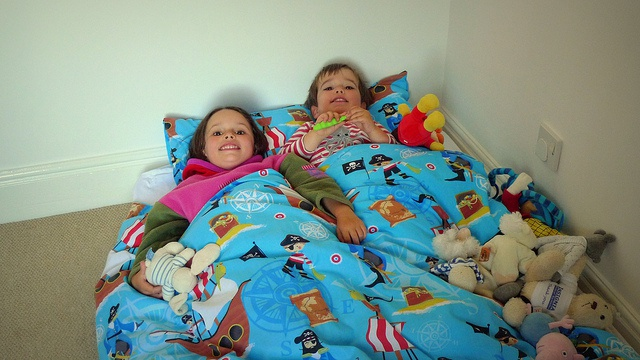Describe the objects in this image and their specific colors. I can see people in darkgray, darkgreen, black, brown, and purple tones, people in darkgray, brown, tan, and black tones, teddy bear in darkgray, tan, gray, and olive tones, teddy bear in darkgray, gray, olive, and black tones, and teddy bear in darkgray and beige tones in this image. 